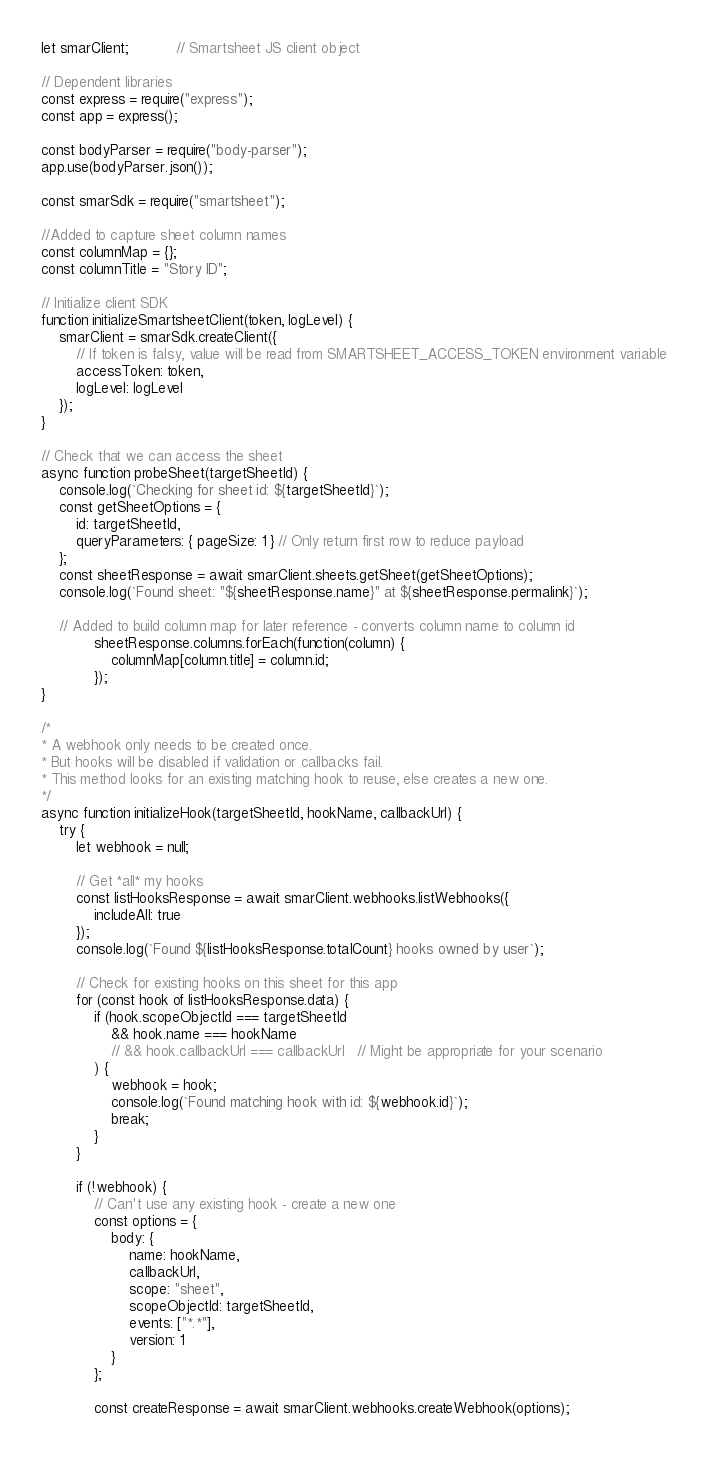<code> <loc_0><loc_0><loc_500><loc_500><_JavaScript_>let smarClient;           // Smartsheet JS client object

// Dependent libraries
const express = require("express");
const app = express();

const bodyParser = require("body-parser");
app.use(bodyParser.json());

const smarSdk = require("smartsheet");

//Added to capture sheet column names
const columnMap = {}; 
const columnTitle = "Story ID";

// Initialize client SDK
function initializeSmartsheetClient(token, logLevel) {
    smarClient = smarSdk.createClient({
        // If token is falsy, value will be read from SMARTSHEET_ACCESS_TOKEN environment variable
        accessToken: token,
        logLevel: logLevel
    });
}

// Check that we can access the sheet
async function probeSheet(targetSheetId) {
    console.log(`Checking for sheet id: ${targetSheetId}`);
    const getSheetOptions = {
        id: targetSheetId,
        queryParameters: { pageSize: 1 } // Only return first row to reduce payload
    };
    const sheetResponse = await smarClient.sheets.getSheet(getSheetOptions);
    console.log(`Found sheet: "${sheetResponse.name}" at ${sheetResponse.permalink}`);
    
    // Added to build column map for later reference - converts column name to column id
            sheetResponse.columns.forEach(function(column) {
                columnMap[column.title] = column.id;
            });
}

/*
* A webhook only needs to be created once.
* But hooks will be disabled if validation or callbacks fail.
* This method looks for an existing matching hook to reuse, else creates a new one.
*/
async function initializeHook(targetSheetId, hookName, callbackUrl) {
    try {
        let webhook = null;

        // Get *all* my hooks
        const listHooksResponse = await smarClient.webhooks.listWebhooks({
            includeAll: true
        });
        console.log(`Found ${listHooksResponse.totalCount} hooks owned by user`);

        // Check for existing hooks on this sheet for this app
        for (const hook of listHooksResponse.data) {
            if (hook.scopeObjectId === targetSheetId
                && hook.name === hookName
                // && hook.callbackUrl === callbackUrl   // Might be appropriate for your scenario
            ) {
                webhook = hook;
                console.log(`Found matching hook with id: ${webhook.id}`);
                break;
            }
        }

        if (!webhook) {
            // Can't use any existing hook - create a new one
            const options = {
                body: {
                    name: hookName,
                    callbackUrl,
                    scope: "sheet",
                    scopeObjectId: targetSheetId,
                    events: ["*.*"],
                    version: 1
                }
            };

            const createResponse = await smarClient.webhooks.createWebhook(options);</code> 